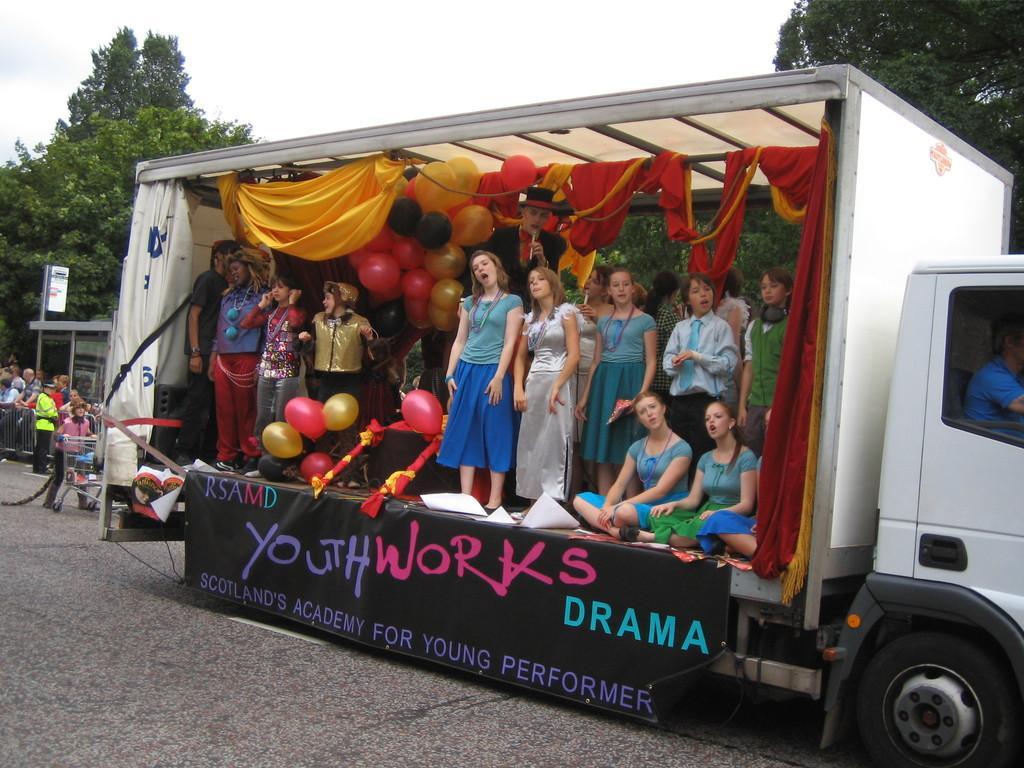In one or two sentences, can you explain what this image depicts? In this image we can see a few people, some of them are in a vehicle, which is decorated with balloons, and cloth, a person is holding mic and talking, we can see a banner with some texts on it, tied to the vehicle, there is a carrier, fencing, trees and the sky. 